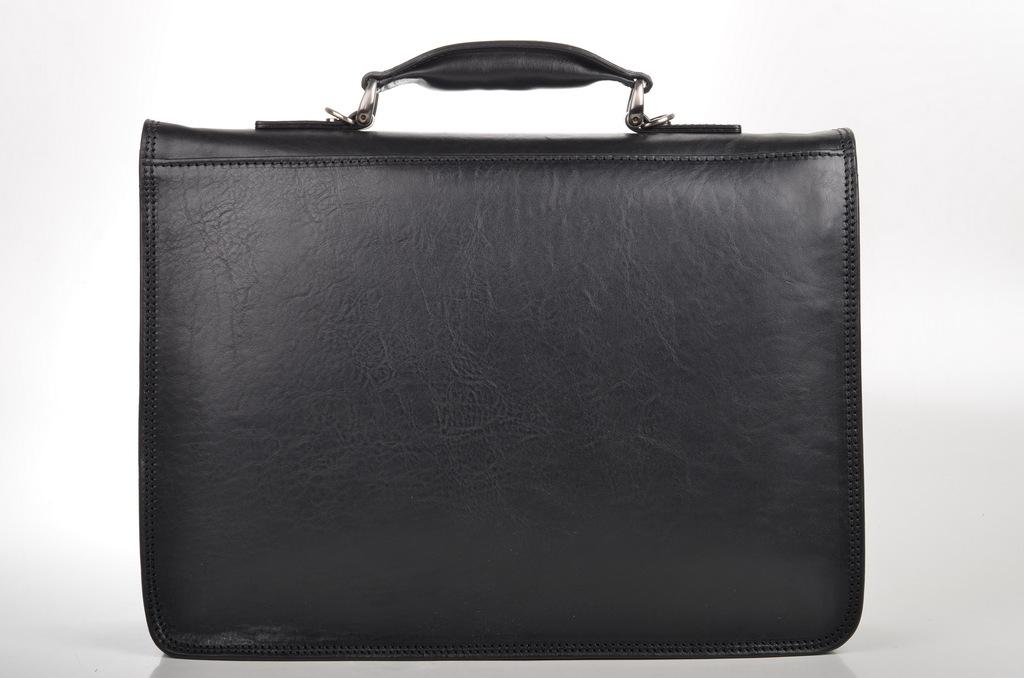What is the color of the bag in the image? The bag in the image is black. What feature does the bag have for carrying purposes? The bag has a handle. Where is the bag located in the image? The bag is in the middle of the image. How many rings are visible on the branch in the image? There is no branch or rings present in the image. 